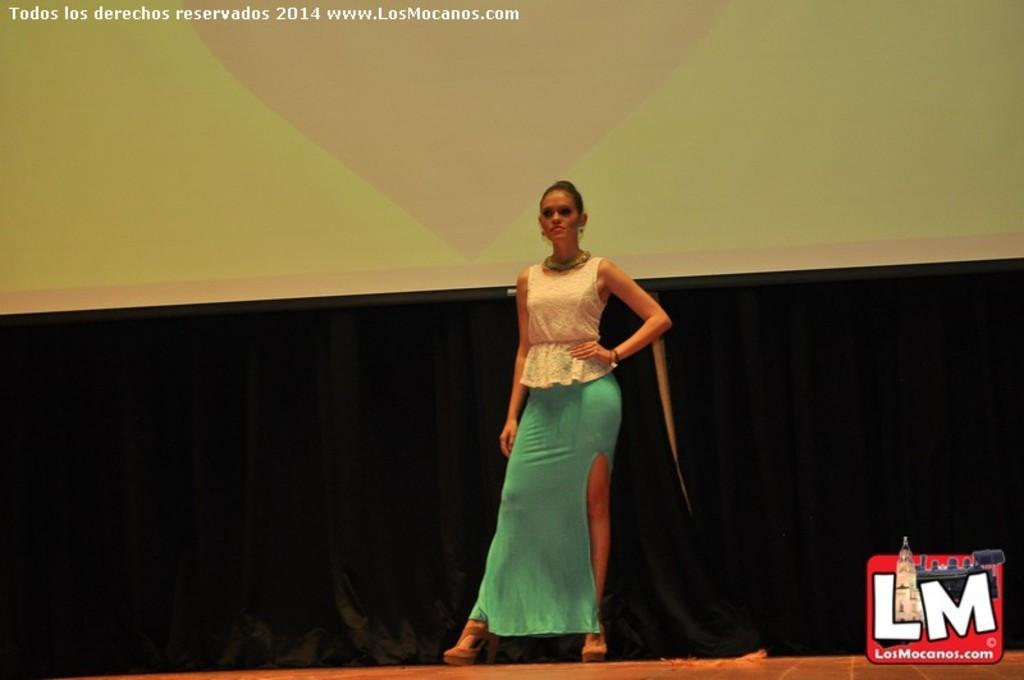Could you give a brief overview of what you see in this image? In this picture I can see a woman standing, and in the background there is a screen, curtains and there are watermarks on the image. 